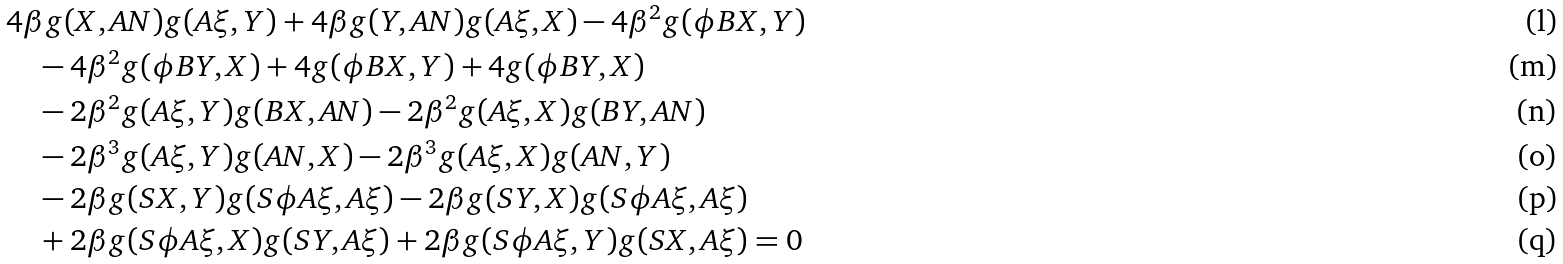Convert formula to latex. <formula><loc_0><loc_0><loc_500><loc_500>& 4 \beta g ( X , A N ) g ( A \xi , Y ) + 4 \beta g ( Y , A N ) g ( A \xi , X ) - 4 \beta ^ { 2 } g ( \phi B X , Y ) \\ & \quad - 4 \beta ^ { 2 } g ( \phi B Y , X ) + 4 g ( \phi B X , Y ) + 4 g ( \phi B Y , X ) \\ & \quad - 2 \beta ^ { 2 } g ( A \xi , Y ) g ( B X , A N ) - 2 \beta ^ { 2 } g ( A \xi , X ) g ( B Y , A N ) \\ & \quad - 2 \beta ^ { 3 } g ( A \xi , Y ) g ( A N , X ) - 2 \beta ^ { 3 } g ( A \xi , X ) g ( A N , Y ) \\ & \quad - 2 \beta g ( S X , Y ) g ( S \phi A \xi , A \xi ) - 2 \beta g ( S Y , X ) g ( S \phi A \xi , A \xi ) \\ & \quad + 2 \beta g ( S \phi A \xi , X ) g ( S Y , A \xi ) + 2 \beta g ( S \phi A \xi , Y ) g ( S X , A \xi ) = 0</formula> 